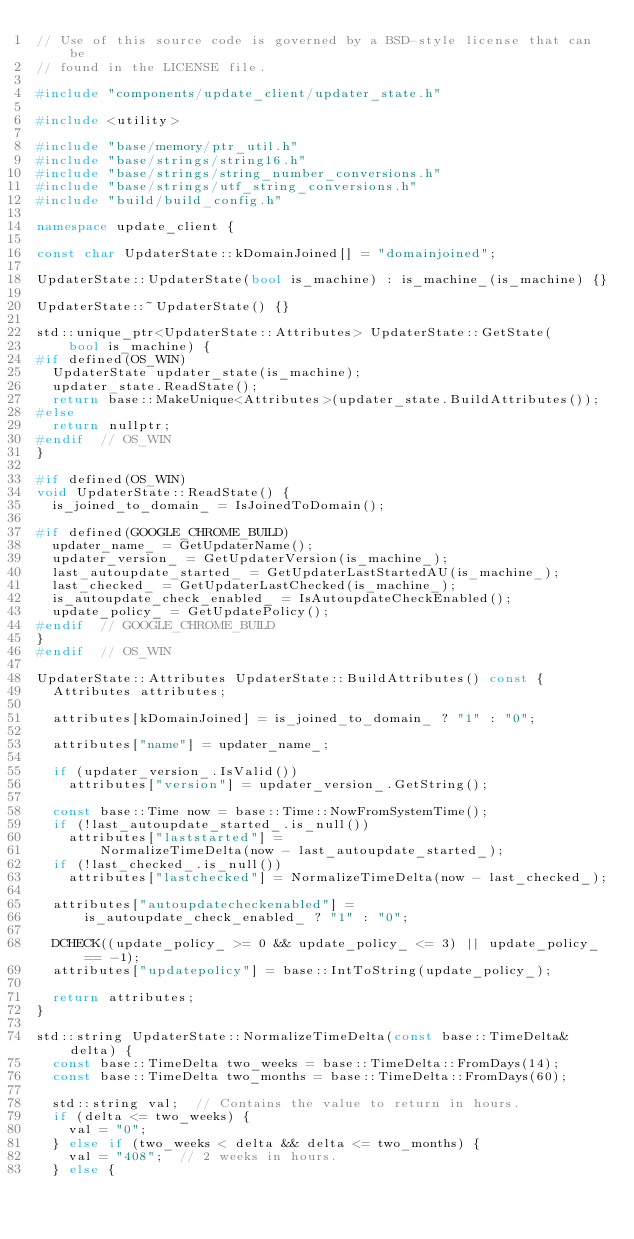<code> <loc_0><loc_0><loc_500><loc_500><_C++_>// Use of this source code is governed by a BSD-style license that can be
// found in the LICENSE file.

#include "components/update_client/updater_state.h"

#include <utility>

#include "base/memory/ptr_util.h"
#include "base/strings/string16.h"
#include "base/strings/string_number_conversions.h"
#include "base/strings/utf_string_conversions.h"
#include "build/build_config.h"

namespace update_client {

const char UpdaterState::kDomainJoined[] = "domainjoined";

UpdaterState::UpdaterState(bool is_machine) : is_machine_(is_machine) {}

UpdaterState::~UpdaterState() {}

std::unique_ptr<UpdaterState::Attributes> UpdaterState::GetState(
    bool is_machine) {
#if defined(OS_WIN)
  UpdaterState updater_state(is_machine);
  updater_state.ReadState();
  return base::MakeUnique<Attributes>(updater_state.BuildAttributes());
#else
  return nullptr;
#endif  // OS_WIN
}

#if defined(OS_WIN)
void UpdaterState::ReadState() {
  is_joined_to_domain_ = IsJoinedToDomain();

#if defined(GOOGLE_CHROME_BUILD)
  updater_name_ = GetUpdaterName();
  updater_version_ = GetUpdaterVersion(is_machine_);
  last_autoupdate_started_ = GetUpdaterLastStartedAU(is_machine_);
  last_checked_ = GetUpdaterLastChecked(is_machine_);
  is_autoupdate_check_enabled_ = IsAutoupdateCheckEnabled();
  update_policy_ = GetUpdatePolicy();
#endif  // GOOGLE_CHROME_BUILD
}
#endif  // OS_WIN

UpdaterState::Attributes UpdaterState::BuildAttributes() const {
  Attributes attributes;

  attributes[kDomainJoined] = is_joined_to_domain_ ? "1" : "0";

  attributes["name"] = updater_name_;

  if (updater_version_.IsValid())
    attributes["version"] = updater_version_.GetString();

  const base::Time now = base::Time::NowFromSystemTime();
  if (!last_autoupdate_started_.is_null())
    attributes["laststarted"] =
        NormalizeTimeDelta(now - last_autoupdate_started_);
  if (!last_checked_.is_null())
    attributes["lastchecked"] = NormalizeTimeDelta(now - last_checked_);

  attributes["autoupdatecheckenabled"] =
      is_autoupdate_check_enabled_ ? "1" : "0";

  DCHECK((update_policy_ >= 0 && update_policy_ <= 3) || update_policy_ == -1);
  attributes["updatepolicy"] = base::IntToString(update_policy_);

  return attributes;
}

std::string UpdaterState::NormalizeTimeDelta(const base::TimeDelta& delta) {
  const base::TimeDelta two_weeks = base::TimeDelta::FromDays(14);
  const base::TimeDelta two_months = base::TimeDelta::FromDays(60);

  std::string val;  // Contains the value to return in hours.
  if (delta <= two_weeks) {
    val = "0";
  } else if (two_weeks < delta && delta <= two_months) {
    val = "408";  // 2 weeks in hours.
  } else {</code> 